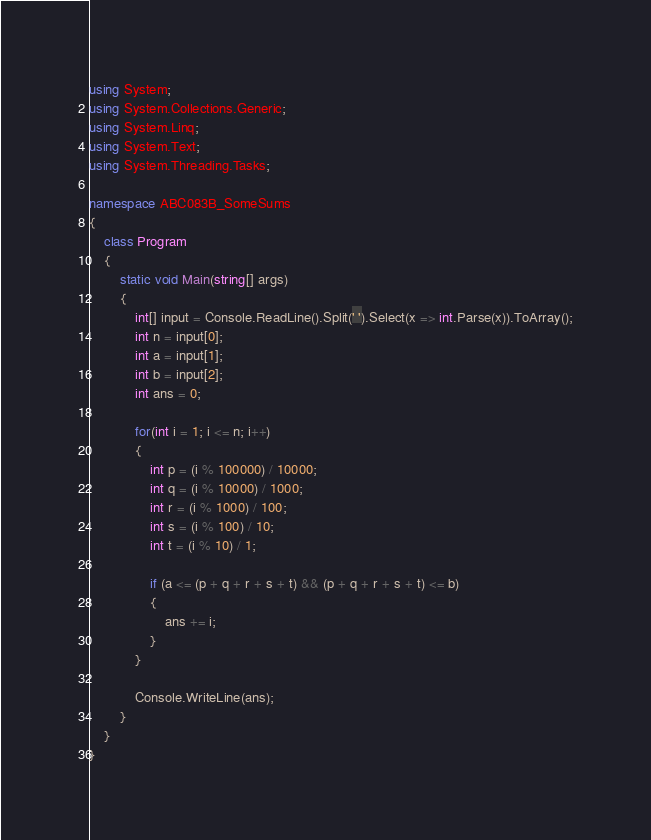Convert code to text. <code><loc_0><loc_0><loc_500><loc_500><_C#_>using System;
using System.Collections.Generic;
using System.Linq;
using System.Text;
using System.Threading.Tasks;

namespace ABC083B_SomeSums
{
    class Program
    {
        static void Main(string[] args)
        {
            int[] input = Console.ReadLine().Split(' ').Select(x => int.Parse(x)).ToArray();
            int n = input[0];
            int a = input[1];
            int b = input[2];
            int ans = 0;

            for(int i = 1; i <= n; i++)
            {
                int p = (i % 100000) / 10000;
                int q = (i % 10000) / 1000;
                int r = (i % 1000) / 100;
                int s = (i % 100) / 10;
                int t = (i % 10) / 1;

                if (a <= (p + q + r + s + t) && (p + q + r + s + t) <= b)
                {
                    ans += i;
                }
            }

            Console.WriteLine(ans);
        }
    }
}
</code> 